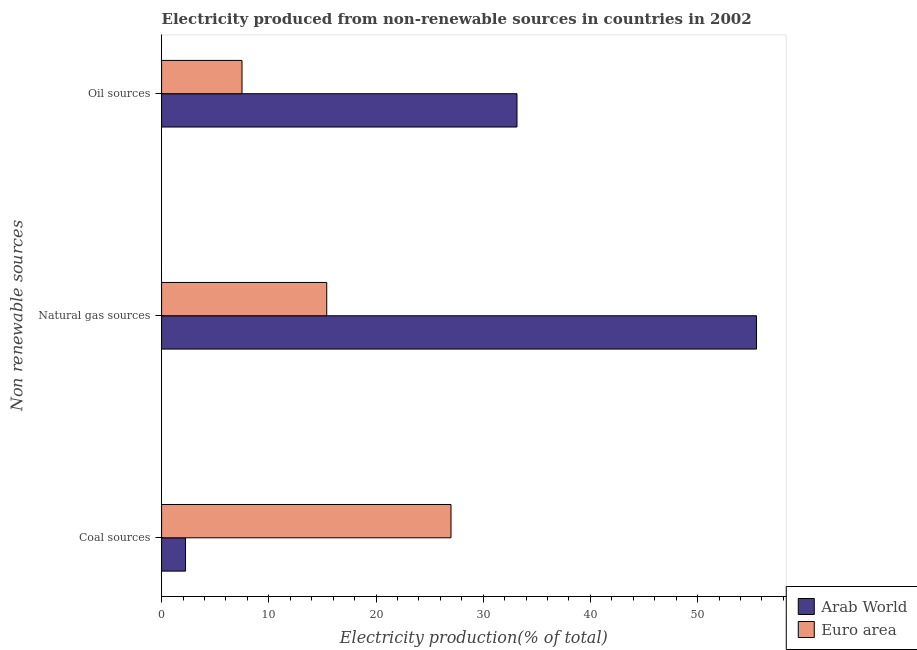How many different coloured bars are there?
Your response must be concise. 2. How many groups of bars are there?
Keep it short and to the point. 3. Are the number of bars on each tick of the Y-axis equal?
Make the answer very short. Yes. What is the label of the 1st group of bars from the top?
Ensure brevity in your answer.  Oil sources. What is the percentage of electricity produced by coal in Arab World?
Offer a terse response. 2.23. Across all countries, what is the maximum percentage of electricity produced by natural gas?
Your answer should be very brief. 55.49. Across all countries, what is the minimum percentage of electricity produced by coal?
Make the answer very short. 2.23. In which country was the percentage of electricity produced by coal minimum?
Offer a very short reply. Arab World. What is the total percentage of electricity produced by oil sources in the graph?
Your answer should be compact. 40.65. What is the difference between the percentage of electricity produced by natural gas in Arab World and that in Euro area?
Provide a succinct answer. 40.09. What is the difference between the percentage of electricity produced by oil sources in Euro area and the percentage of electricity produced by coal in Arab World?
Your answer should be compact. 5.27. What is the average percentage of electricity produced by natural gas per country?
Your answer should be very brief. 35.45. What is the difference between the percentage of electricity produced by oil sources and percentage of electricity produced by coal in Arab World?
Provide a short and direct response. 30.92. What is the ratio of the percentage of electricity produced by coal in Euro area to that in Arab World?
Offer a very short reply. 12.1. What is the difference between the highest and the second highest percentage of electricity produced by natural gas?
Your answer should be very brief. 40.09. What is the difference between the highest and the lowest percentage of electricity produced by oil sources?
Provide a succinct answer. 25.65. Is the sum of the percentage of electricity produced by coal in Arab World and Euro area greater than the maximum percentage of electricity produced by natural gas across all countries?
Your answer should be compact. No. What does the 2nd bar from the top in Oil sources represents?
Offer a very short reply. Arab World. What does the 2nd bar from the bottom in Oil sources represents?
Offer a terse response. Euro area. Is it the case that in every country, the sum of the percentage of electricity produced by coal and percentage of electricity produced by natural gas is greater than the percentage of electricity produced by oil sources?
Your response must be concise. Yes. How many bars are there?
Offer a very short reply. 6. How many countries are there in the graph?
Make the answer very short. 2. Are the values on the major ticks of X-axis written in scientific E-notation?
Ensure brevity in your answer.  No. How many legend labels are there?
Your answer should be compact. 2. How are the legend labels stacked?
Make the answer very short. Vertical. What is the title of the graph?
Offer a terse response. Electricity produced from non-renewable sources in countries in 2002. Does "Namibia" appear as one of the legend labels in the graph?
Your response must be concise. No. What is the label or title of the Y-axis?
Your answer should be very brief. Non renewable sources. What is the Electricity production(% of total) of Arab World in Coal sources?
Ensure brevity in your answer.  2.23. What is the Electricity production(% of total) of Euro area in Coal sources?
Your response must be concise. 27. What is the Electricity production(% of total) of Arab World in Natural gas sources?
Provide a succinct answer. 55.49. What is the Electricity production(% of total) of Euro area in Natural gas sources?
Keep it short and to the point. 15.41. What is the Electricity production(% of total) in Arab World in Oil sources?
Offer a terse response. 33.15. What is the Electricity production(% of total) of Euro area in Oil sources?
Give a very brief answer. 7.5. Across all Non renewable sources, what is the maximum Electricity production(% of total) in Arab World?
Offer a terse response. 55.49. Across all Non renewable sources, what is the maximum Electricity production(% of total) of Euro area?
Provide a succinct answer. 27. Across all Non renewable sources, what is the minimum Electricity production(% of total) in Arab World?
Ensure brevity in your answer.  2.23. Across all Non renewable sources, what is the minimum Electricity production(% of total) in Euro area?
Your answer should be very brief. 7.5. What is the total Electricity production(% of total) in Arab World in the graph?
Your response must be concise. 90.87. What is the total Electricity production(% of total) of Euro area in the graph?
Offer a very short reply. 49.9. What is the difference between the Electricity production(% of total) of Arab World in Coal sources and that in Natural gas sources?
Your answer should be very brief. -53.26. What is the difference between the Electricity production(% of total) in Euro area in Coal sources and that in Natural gas sources?
Provide a succinct answer. 11.59. What is the difference between the Electricity production(% of total) in Arab World in Coal sources and that in Oil sources?
Ensure brevity in your answer.  -30.92. What is the difference between the Electricity production(% of total) of Euro area in Coal sources and that in Oil sources?
Your response must be concise. 19.49. What is the difference between the Electricity production(% of total) in Arab World in Natural gas sources and that in Oil sources?
Provide a short and direct response. 22.34. What is the difference between the Electricity production(% of total) in Euro area in Natural gas sources and that in Oil sources?
Your answer should be very brief. 7.9. What is the difference between the Electricity production(% of total) in Arab World in Coal sources and the Electricity production(% of total) in Euro area in Natural gas sources?
Your answer should be very brief. -13.17. What is the difference between the Electricity production(% of total) in Arab World in Coal sources and the Electricity production(% of total) in Euro area in Oil sources?
Provide a short and direct response. -5.27. What is the difference between the Electricity production(% of total) of Arab World in Natural gas sources and the Electricity production(% of total) of Euro area in Oil sources?
Your response must be concise. 47.99. What is the average Electricity production(% of total) of Arab World per Non renewable sources?
Make the answer very short. 30.29. What is the average Electricity production(% of total) of Euro area per Non renewable sources?
Your answer should be very brief. 16.63. What is the difference between the Electricity production(% of total) in Arab World and Electricity production(% of total) in Euro area in Coal sources?
Provide a succinct answer. -24.77. What is the difference between the Electricity production(% of total) of Arab World and Electricity production(% of total) of Euro area in Natural gas sources?
Ensure brevity in your answer.  40.09. What is the difference between the Electricity production(% of total) of Arab World and Electricity production(% of total) of Euro area in Oil sources?
Provide a succinct answer. 25.65. What is the ratio of the Electricity production(% of total) of Arab World in Coal sources to that in Natural gas sources?
Your answer should be very brief. 0.04. What is the ratio of the Electricity production(% of total) of Euro area in Coal sources to that in Natural gas sources?
Give a very brief answer. 1.75. What is the ratio of the Electricity production(% of total) in Arab World in Coal sources to that in Oil sources?
Keep it short and to the point. 0.07. What is the ratio of the Electricity production(% of total) of Euro area in Coal sources to that in Oil sources?
Offer a very short reply. 3.6. What is the ratio of the Electricity production(% of total) of Arab World in Natural gas sources to that in Oil sources?
Your response must be concise. 1.67. What is the ratio of the Electricity production(% of total) of Euro area in Natural gas sources to that in Oil sources?
Your answer should be compact. 2.05. What is the difference between the highest and the second highest Electricity production(% of total) of Arab World?
Give a very brief answer. 22.34. What is the difference between the highest and the second highest Electricity production(% of total) of Euro area?
Keep it short and to the point. 11.59. What is the difference between the highest and the lowest Electricity production(% of total) in Arab World?
Your answer should be very brief. 53.26. What is the difference between the highest and the lowest Electricity production(% of total) of Euro area?
Offer a very short reply. 19.49. 